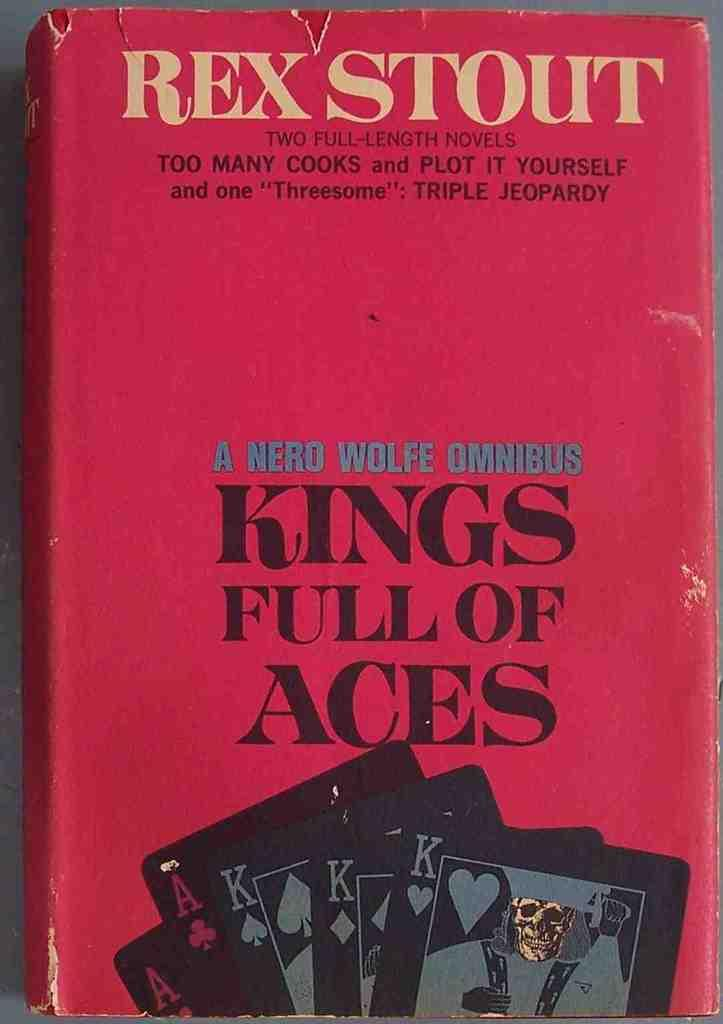<image>
Create a compact narrative representing the image presented. Red Vintage Book Kings Full of Aces by Rex Stout. 